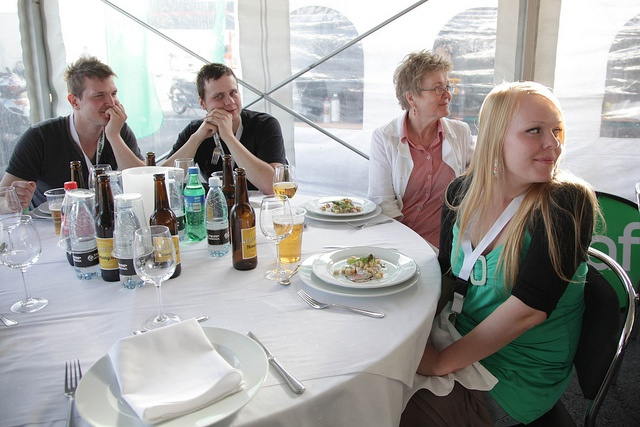Describe the objects in this image and their specific colors. I can see dining table in white, lightgray, darkgray, and gray tones, people in white, black, gray, darkgreen, and darkgray tones, people in white, darkgray, brown, and lightgray tones, people in white, black, gray, and darkgray tones, and people in white, black, gray, and darkgray tones in this image. 